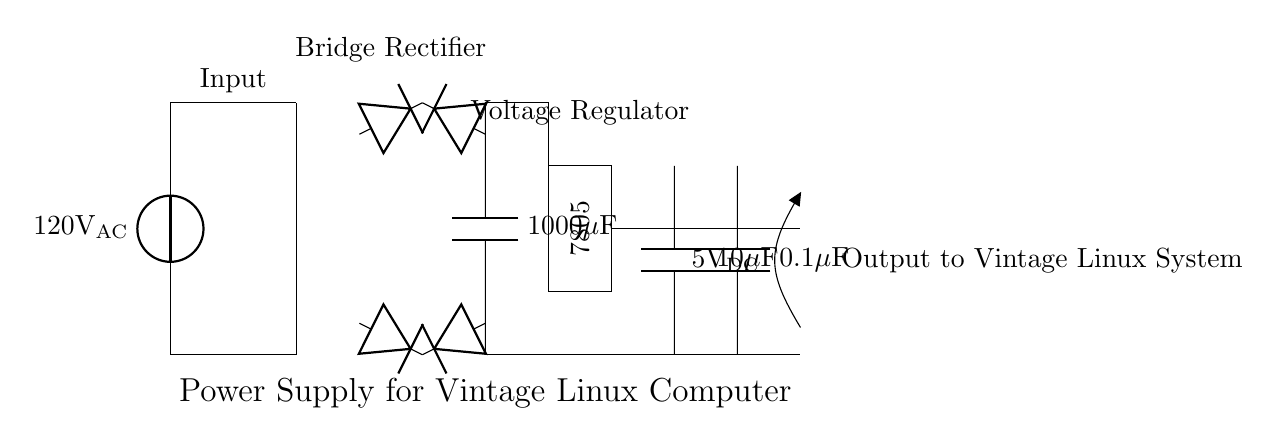What is the input voltage of the circuit? The input voltage is indicated as 120V AC, which is shown by the voltage source at the beginning of the circuit diagram.
Answer: 120V AC What type of rectifier is used in this circuit? A bridge rectifier is used, as seen by the arrangement of four diodes configured in a bridge formation to convert AC to DC.
Answer: Bridge Rectifier What is the value of the smoothing capacitor? The value of the smoothing capacitor is indicated as 1000 microfarads, which can be specifically observed in the circuit labeled with the capacitor symbol.
Answer: 1000 microfarads What voltage does the voltage regulator output? The output voltage of the voltage regulator, typically labeled as 7805, implies an output of 5V DC. This is confirmed by the standard specifications of the 7805 regulator.
Answer: 5V DC How many output capacitors are present, and what are their values? There are two output capacitors: one is 10 microfarads, and the other is 0.1 microfarads, indicated by their respective labels in the circuit.
Answer: Two capacitors, 10 microfarads and 0.1 microfarads What is the purpose of the smoothing capacitor in this circuit? The smoothing capacitor's role is to filter and smooth the output from the rectifier, reducing voltage ripples after rectification and thus stabilizing the DC output for the computer system.
Answer: Smoothing DC output Where do the output connections lead in the circuit? The output connections lead to the vintage Linux system, which is indicated in the diagram near the output terminal labeled as 5V DC.
Answer: To Vintage Linux System 